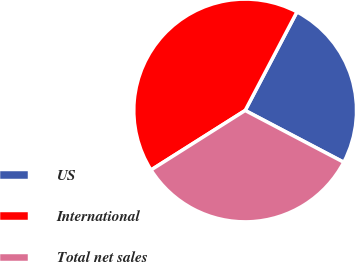Convert chart to OTSL. <chart><loc_0><loc_0><loc_500><loc_500><pie_chart><fcel>US<fcel>International<fcel>Total net sales<nl><fcel>25.0%<fcel>41.67%<fcel>33.33%<nl></chart> 